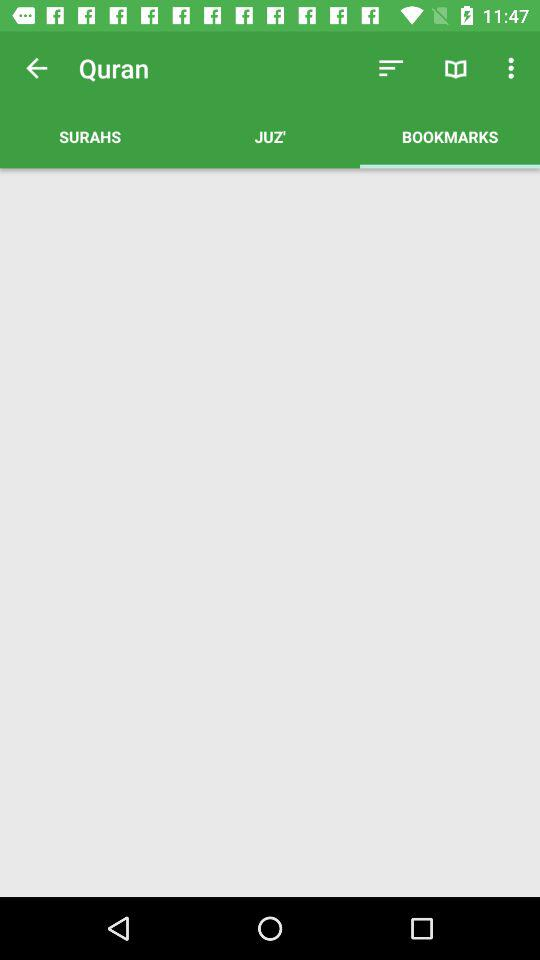What is the name of the application?
When the provided information is insufficient, respond with <no answer>. <no answer> 